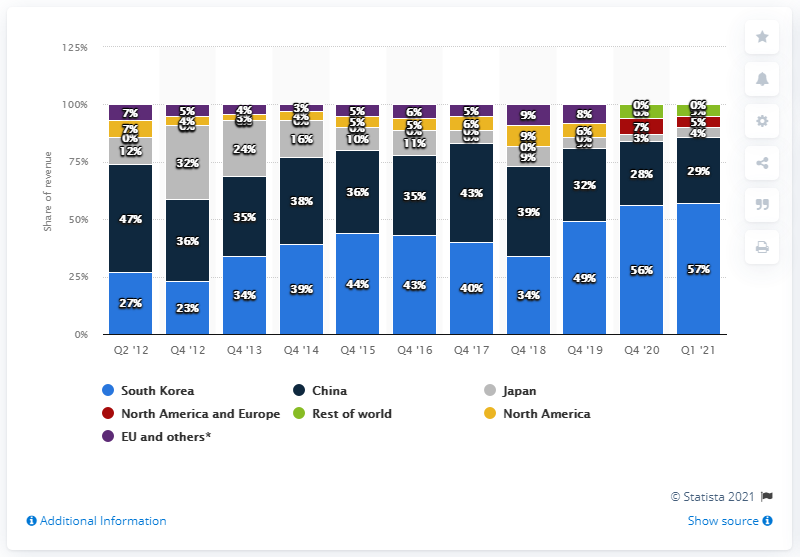Mention a couple of crucial points in this snapshot. Nexon's revenue in China accounted for 29% Nexon's second-largest market was China, where it experienced significant success and growth. Nexon's revenues in the first quarter of 2021 were primarily generated in South Korea. 